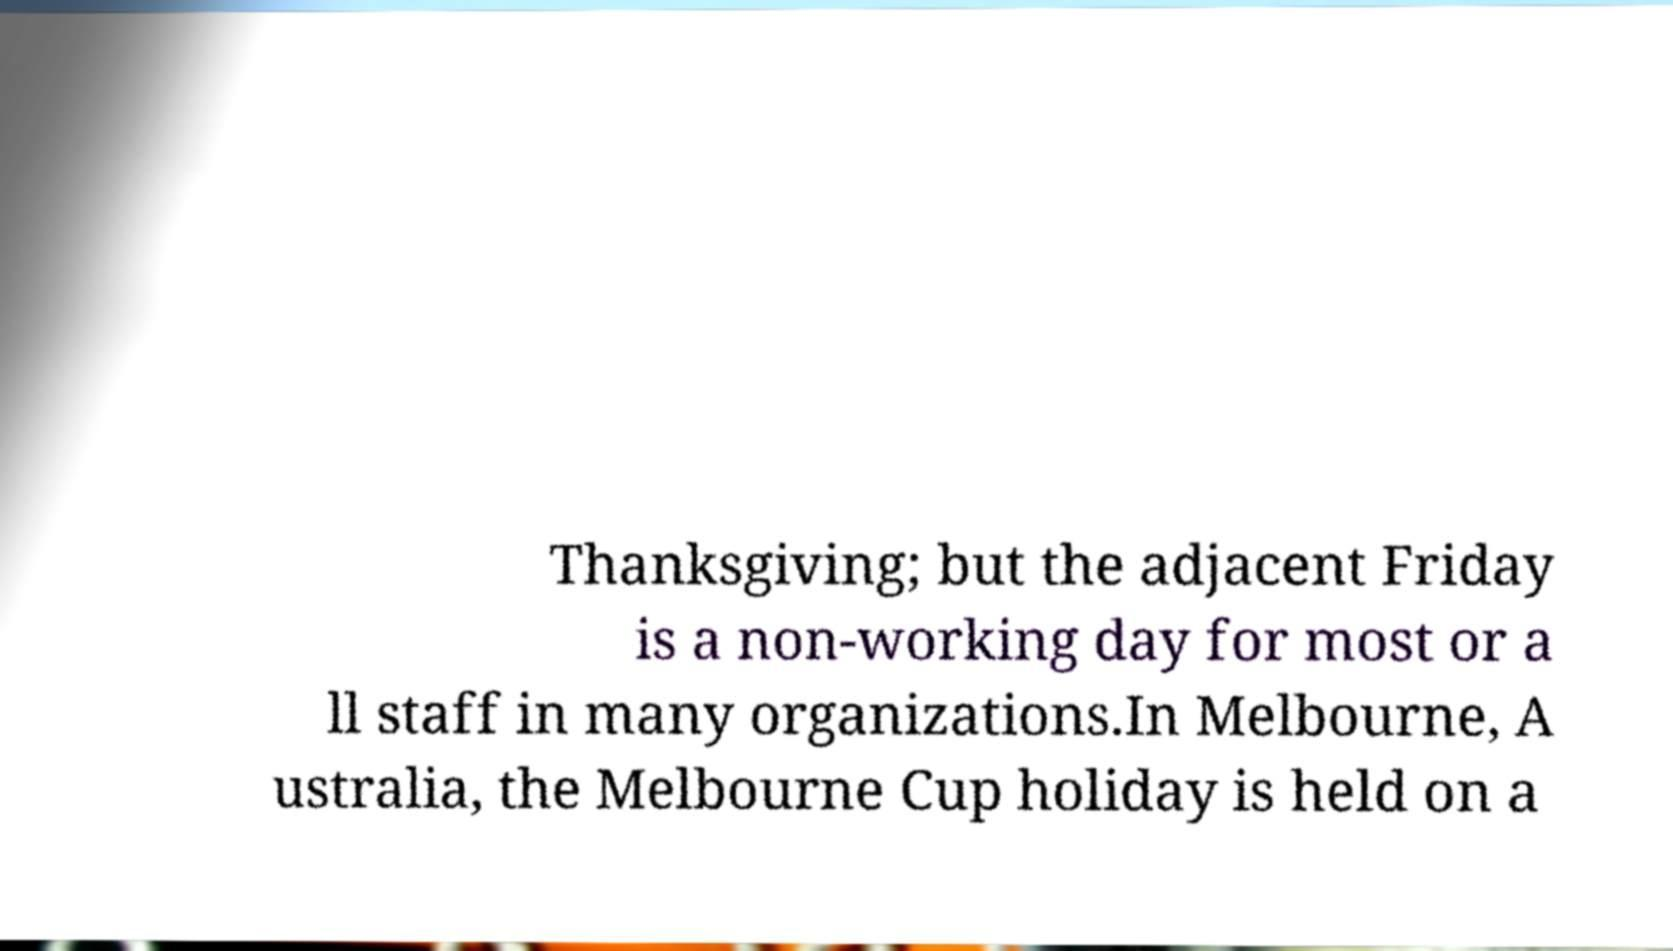What messages or text are displayed in this image? I need them in a readable, typed format. Thanksgiving; but the adjacent Friday is a non-working day for most or a ll staff in many organizations.In Melbourne, A ustralia, the Melbourne Cup holiday is held on a 